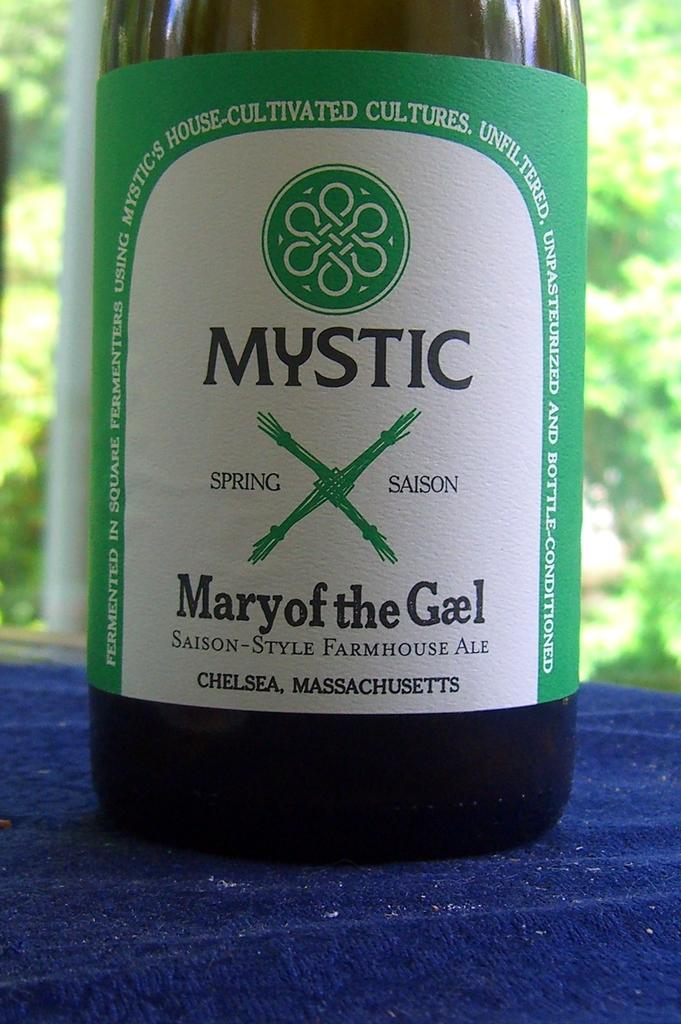<image>
Summarize the visual content of the image. the word mystic is on the front of a bottle 